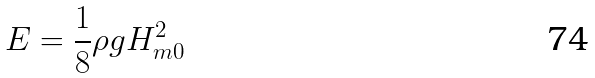Convert formula to latex. <formula><loc_0><loc_0><loc_500><loc_500>E = \frac { 1 } { 8 } \rho g H _ { m 0 } ^ { 2 }</formula> 